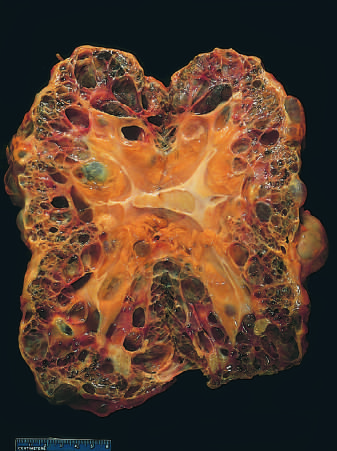s numerous friable mural thrombi shown for scale?
Answer the question using a single word or phrase. No 